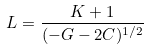<formula> <loc_0><loc_0><loc_500><loc_500>L = \frac { K + 1 } { ( - G - 2 C ) ^ { 1 / 2 } }</formula> 